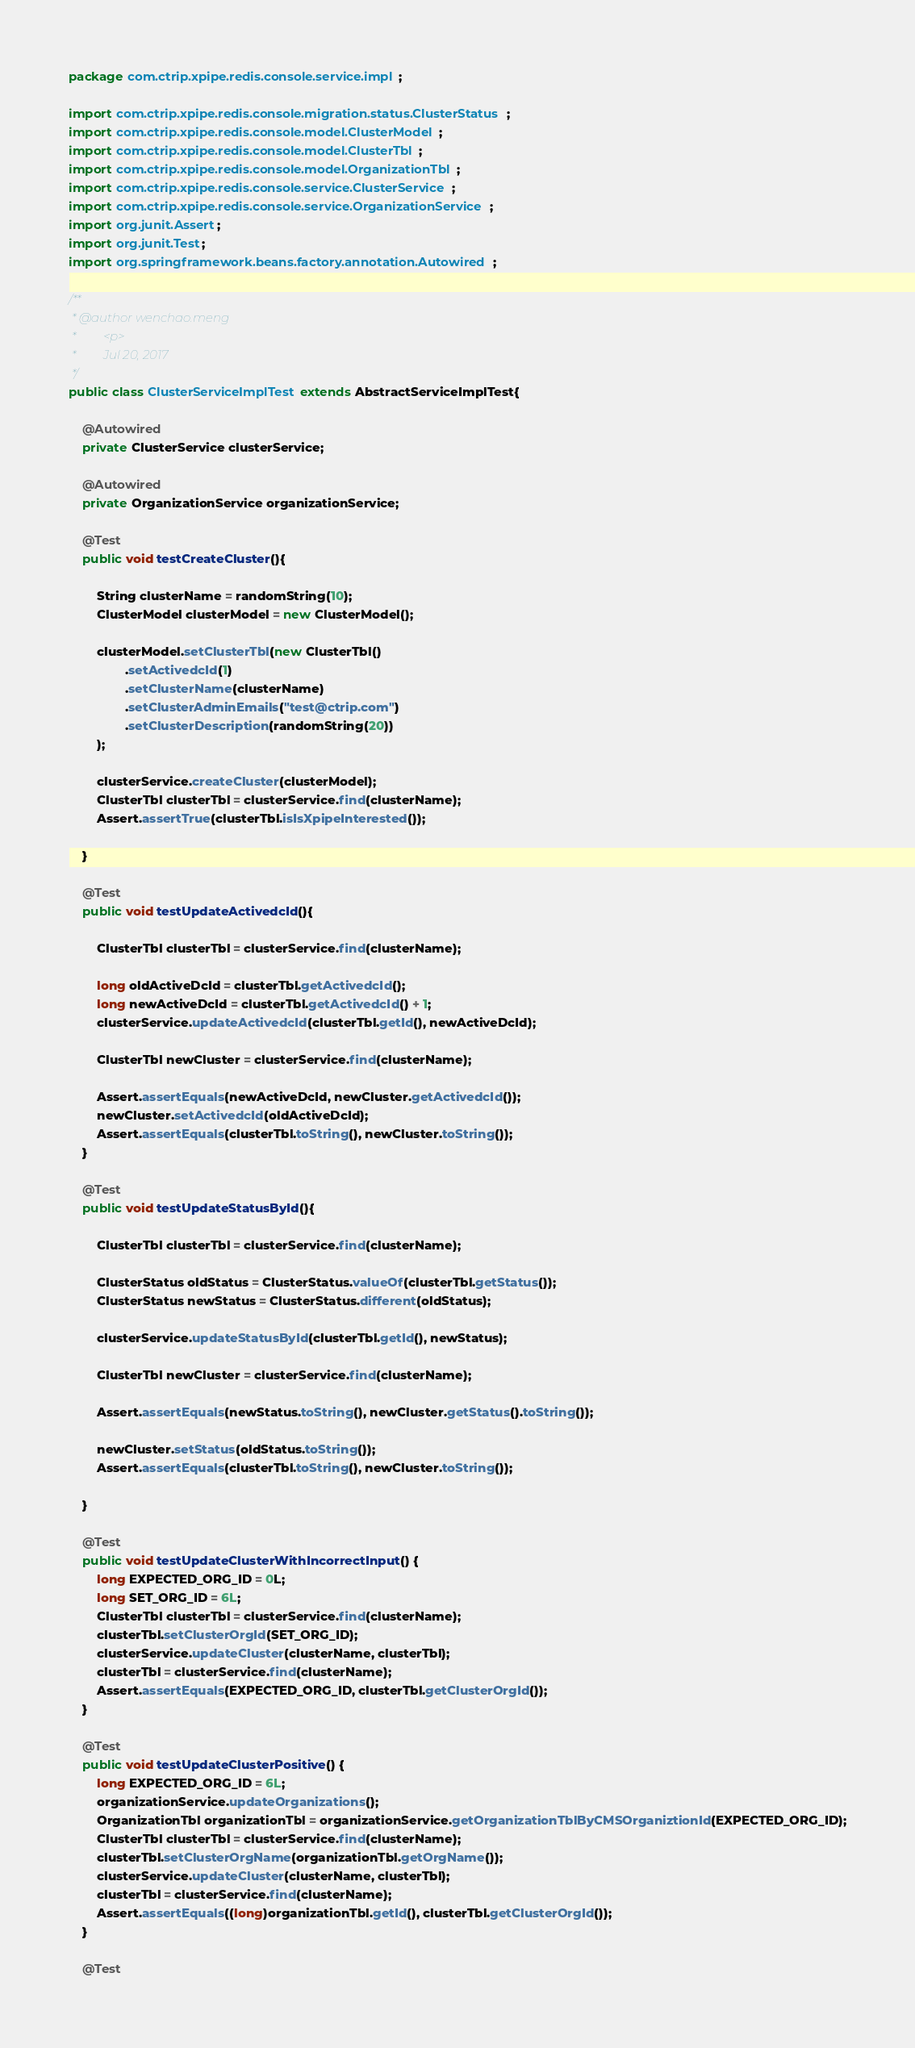<code> <loc_0><loc_0><loc_500><loc_500><_Java_>package com.ctrip.xpipe.redis.console.service.impl;

import com.ctrip.xpipe.redis.console.migration.status.ClusterStatus;
import com.ctrip.xpipe.redis.console.model.ClusterModel;
import com.ctrip.xpipe.redis.console.model.ClusterTbl;
import com.ctrip.xpipe.redis.console.model.OrganizationTbl;
import com.ctrip.xpipe.redis.console.service.ClusterService;
import com.ctrip.xpipe.redis.console.service.OrganizationService;
import org.junit.Assert;
import org.junit.Test;
import org.springframework.beans.factory.annotation.Autowired;

/**
 * @author wenchao.meng
 *         <p>
 *         Jul 20, 2017
 */
public class ClusterServiceImplTest extends AbstractServiceImplTest{

    @Autowired
    private ClusterService clusterService;

    @Autowired
    private OrganizationService organizationService;

    @Test
    public void testCreateCluster(){

        String clusterName = randomString(10);
        ClusterModel clusterModel = new ClusterModel();

        clusterModel.setClusterTbl(new ClusterTbl()
                .setActivedcId(1)
                .setClusterName(clusterName)
                .setClusterAdminEmails("test@ctrip.com")
                .setClusterDescription(randomString(20))
        );

        clusterService.createCluster(clusterModel);
        ClusterTbl clusterTbl = clusterService.find(clusterName);
        Assert.assertTrue(clusterTbl.isIsXpipeInterested());

    }

    @Test
    public void testUpdateActivedcId(){

        ClusterTbl clusterTbl = clusterService.find(clusterName);

        long oldActiveDcId = clusterTbl.getActivedcId();
        long newActiveDcId = clusterTbl.getActivedcId() + 1;
        clusterService.updateActivedcId(clusterTbl.getId(), newActiveDcId);

        ClusterTbl newCluster = clusterService.find(clusterName);

        Assert.assertEquals(newActiveDcId, newCluster.getActivedcId());
        newCluster.setActivedcId(oldActiveDcId);
        Assert.assertEquals(clusterTbl.toString(), newCluster.toString());
    }

    @Test
    public void testUpdateStatusById(){

        ClusterTbl clusterTbl = clusterService.find(clusterName);

        ClusterStatus oldStatus = ClusterStatus.valueOf(clusterTbl.getStatus());
        ClusterStatus newStatus = ClusterStatus.different(oldStatus);

        clusterService.updateStatusById(clusterTbl.getId(), newStatus);

        ClusterTbl newCluster = clusterService.find(clusterName);

        Assert.assertEquals(newStatus.toString(), newCluster.getStatus().toString());

        newCluster.setStatus(oldStatus.toString());
        Assert.assertEquals(clusterTbl.toString(), newCluster.toString());

    }

    @Test
    public void testUpdateClusterWithIncorrectInput() {
        long EXPECTED_ORG_ID = 0L;
        long SET_ORG_ID = 6L;
        ClusterTbl clusterTbl = clusterService.find(clusterName);
        clusterTbl.setClusterOrgId(SET_ORG_ID);
        clusterService.updateCluster(clusterName, clusterTbl);
        clusterTbl = clusterService.find(clusterName);
        Assert.assertEquals(EXPECTED_ORG_ID, clusterTbl.getClusterOrgId());
    }

    @Test
    public void testUpdateClusterPositive() {
        long EXPECTED_ORG_ID = 6L;
        organizationService.updateOrganizations();
        OrganizationTbl organizationTbl = organizationService.getOrganizationTblByCMSOrganiztionId(EXPECTED_ORG_ID);
        ClusterTbl clusterTbl = clusterService.find(clusterName);
        clusterTbl.setClusterOrgName(organizationTbl.getOrgName());
        clusterService.updateCluster(clusterName, clusterTbl);
        clusterTbl = clusterService.find(clusterName);
        Assert.assertEquals((long)organizationTbl.getId(), clusterTbl.getClusterOrgId());
    }

    @Test</code> 